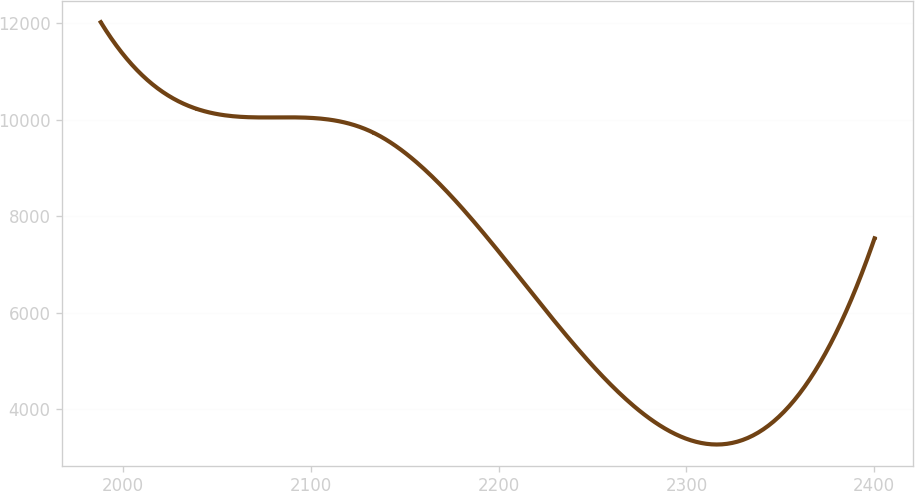<chart> <loc_0><loc_0><loc_500><loc_500><line_chart><ecel><fcel>Unnamed: 1<nl><fcel>1988.19<fcel>12016.6<nl><fcel>2038.7<fcel>10229<nl><fcel>2133.18<fcel>9731.47<nl><fcel>2204.69<fcel>7041.52<nl><fcel>2400.15<fcel>7539.03<nl></chart> 